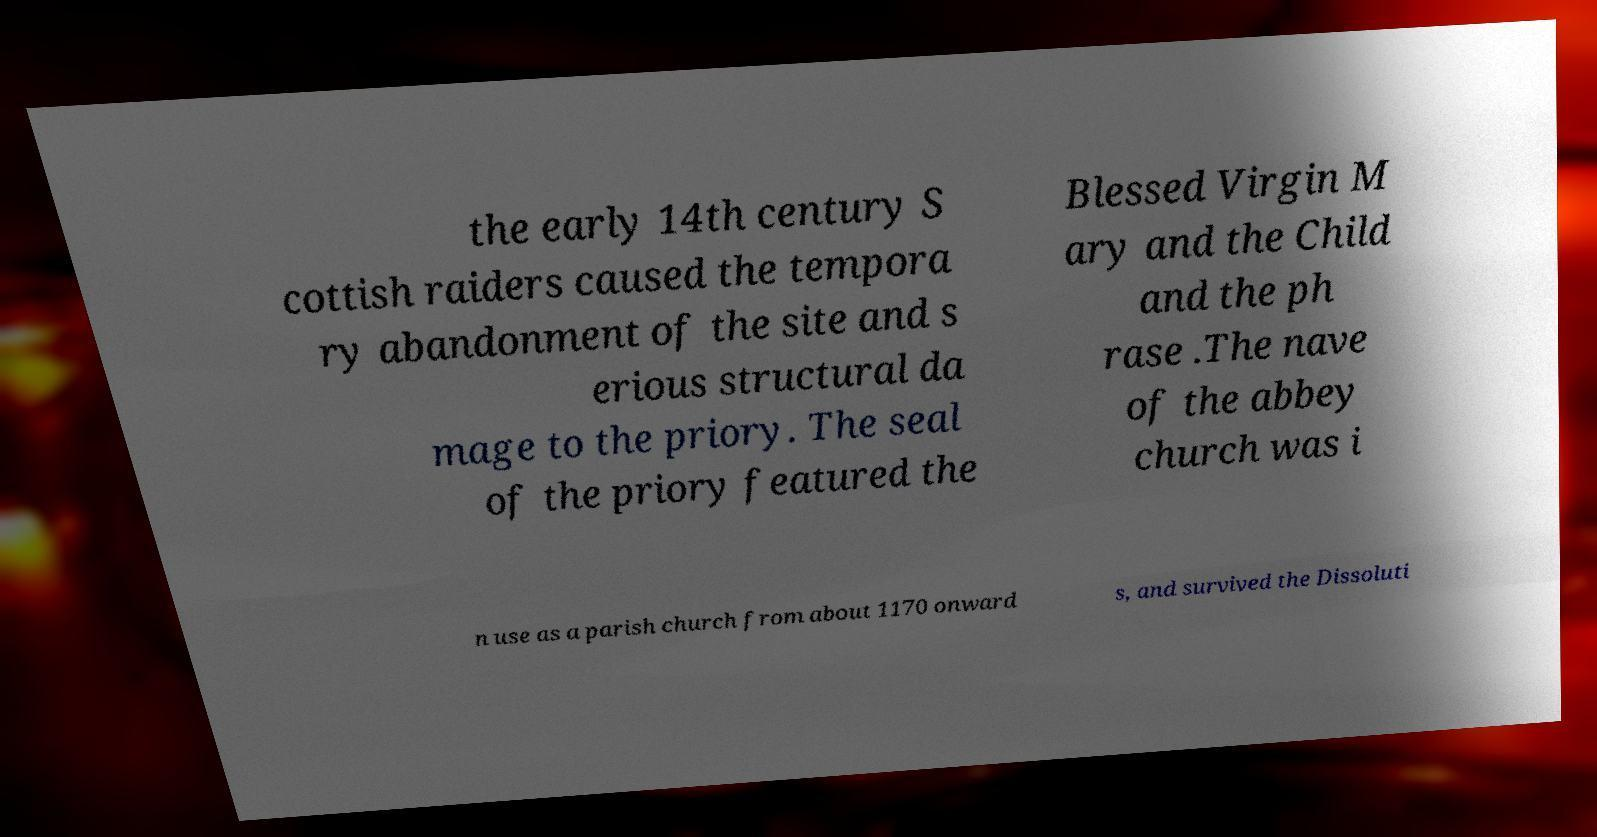For documentation purposes, I need the text within this image transcribed. Could you provide that? the early 14th century S cottish raiders caused the tempora ry abandonment of the site and s erious structural da mage to the priory. The seal of the priory featured the Blessed Virgin M ary and the Child and the ph rase .The nave of the abbey church was i n use as a parish church from about 1170 onward s, and survived the Dissoluti 